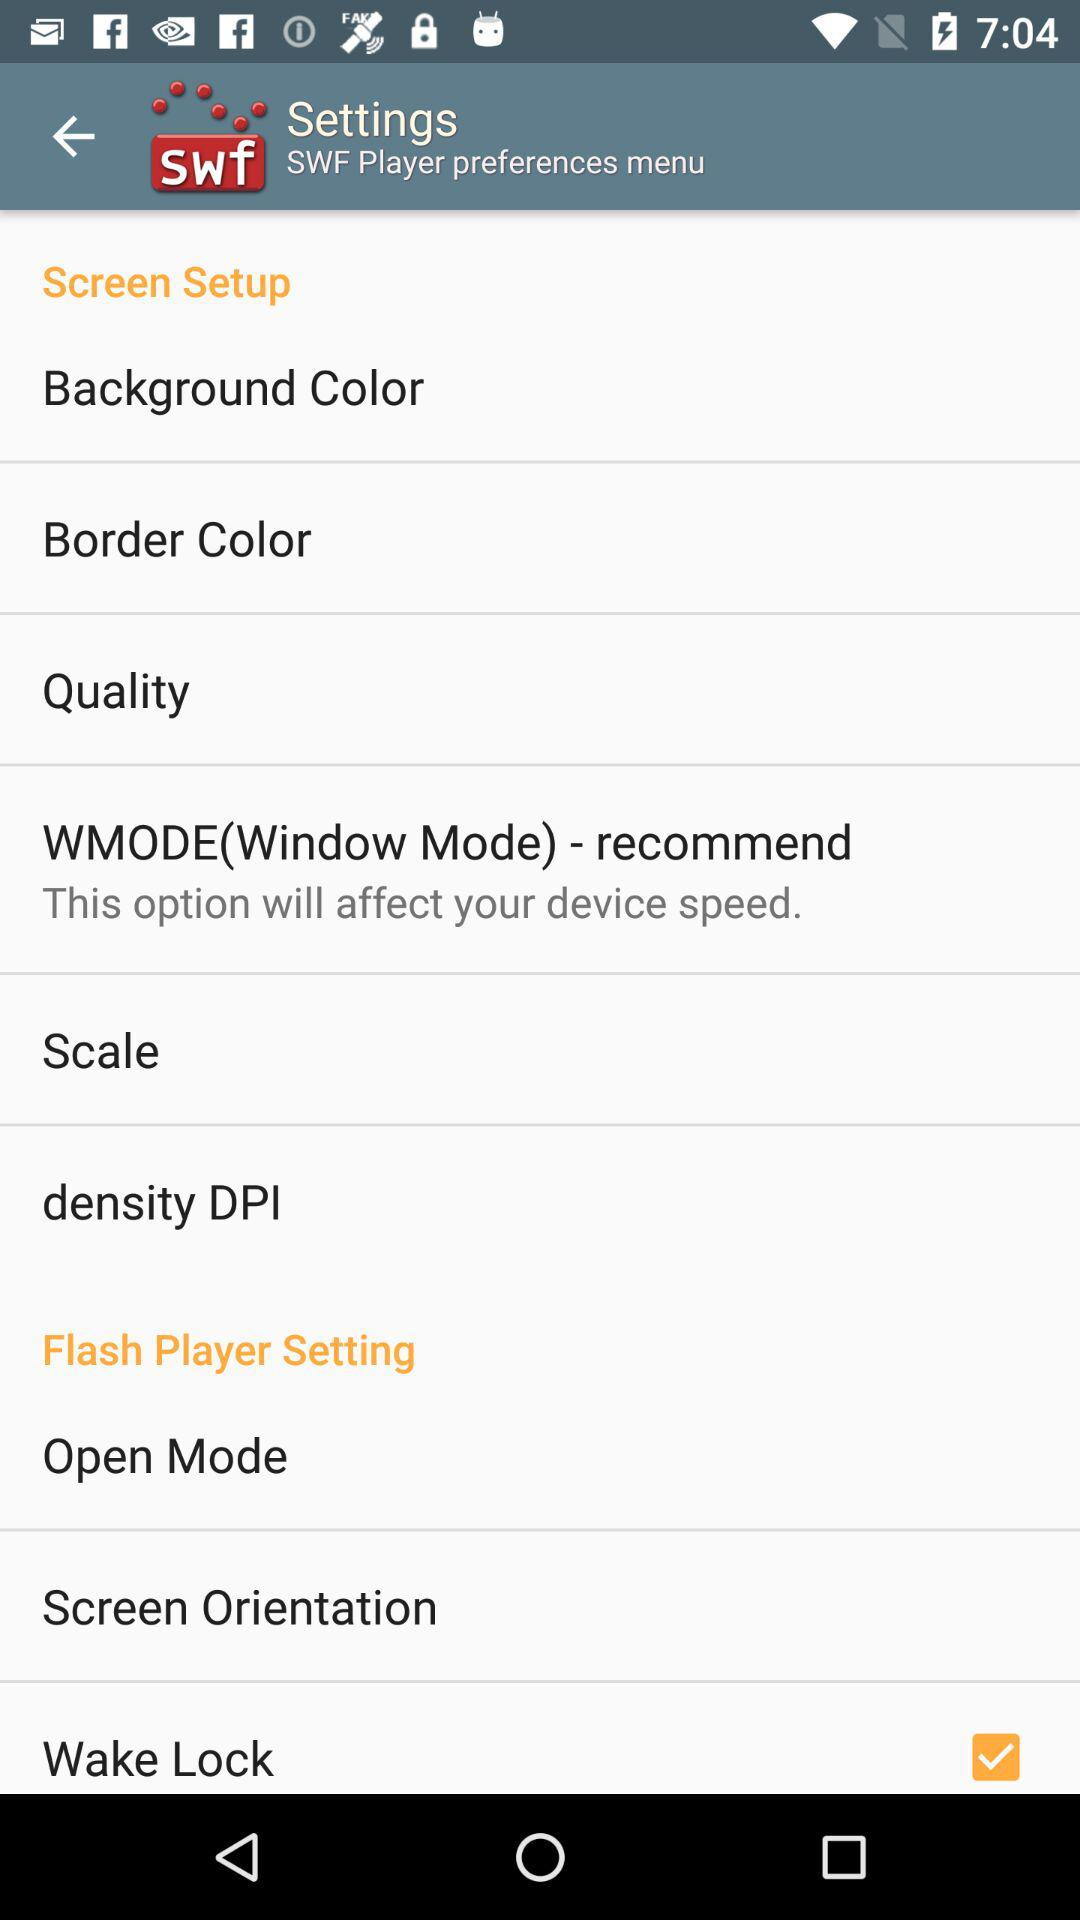What option will affect the device speed? The option is "WMODE(Window Mode)-recommended". 